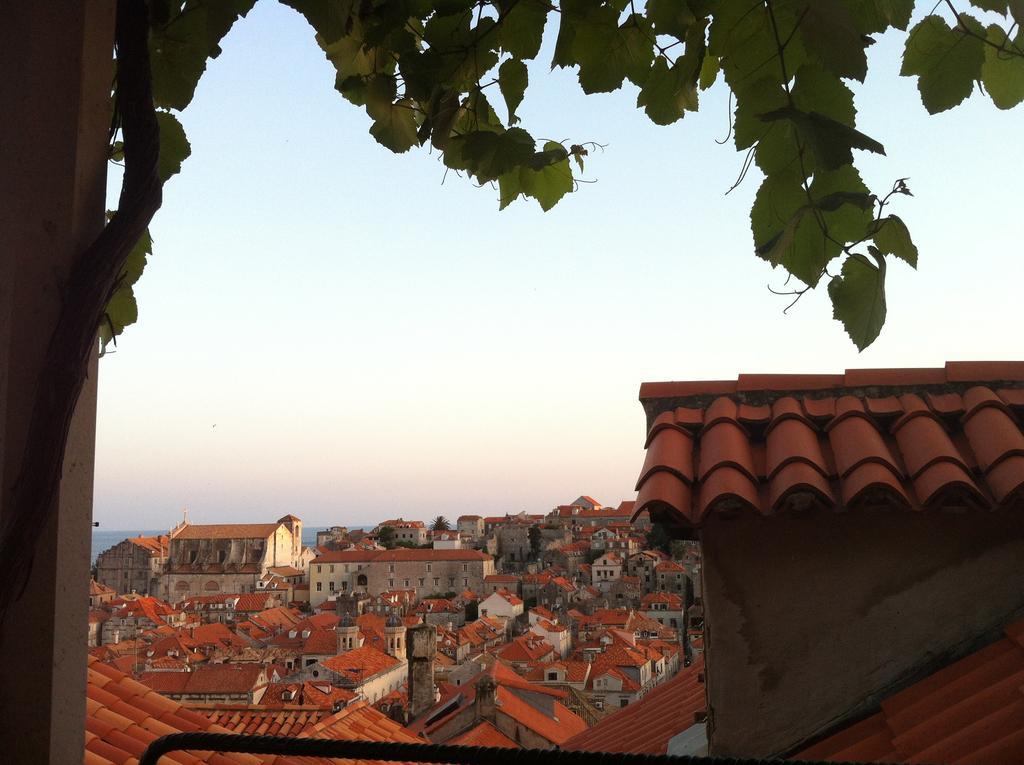Can you describe this image briefly? In the image we can see there are many buildings and we can even see the windows of the building. There is a tree, pillar, water and a sky. 